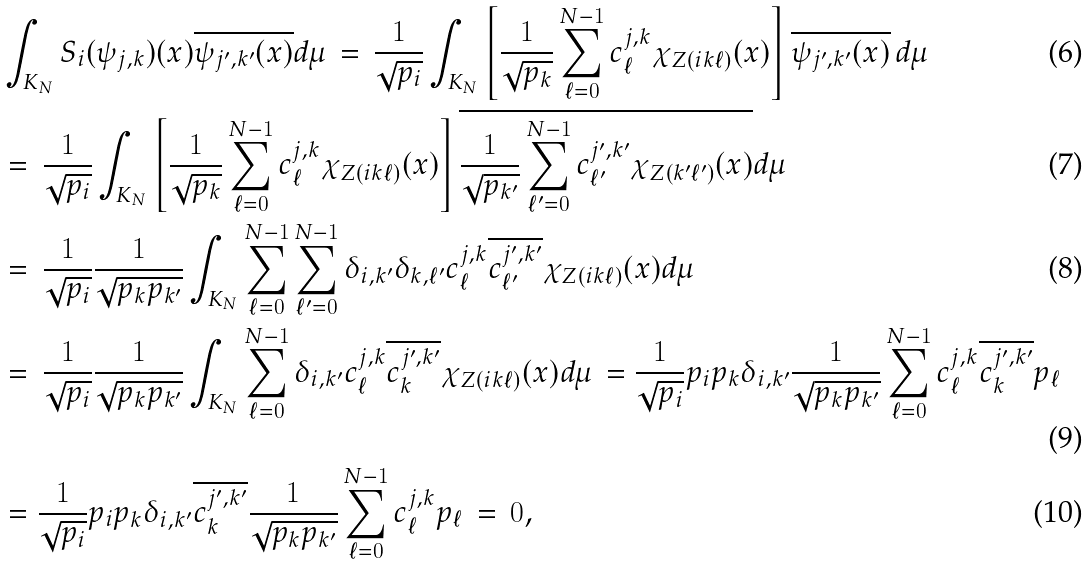<formula> <loc_0><loc_0><loc_500><loc_500>& \int _ { K _ { N } } S _ { i } ( \psi _ { j , k } ) ( x ) \overline { \psi _ { j ^ { \prime } , k ^ { \prime } } ( x ) } d \mu \, = \, \frac { 1 } { \sqrt { p _ { i } } } \int _ { K _ { N } } \left [ \frac { 1 } { \sqrt { p _ { k } } } \sum _ { \ell = 0 } ^ { N - 1 } c ^ { j , k } _ { \ell } \chi _ { Z ( i k \ell ) } ( x ) \right ] \overline { \psi _ { j ^ { \prime } , k ^ { \prime } } ( x ) } \, d \mu \\ & = \, \frac { 1 } { \sqrt { p _ { i } } } \int _ { K _ { N } } \left [ \frac { 1 } { \sqrt { p _ { k } } } \sum _ { \ell = 0 } ^ { N - 1 } c ^ { j , k } _ { \ell } \chi _ { Z ( i k \ell ) } ( x ) \right ] \overline { \frac { 1 } { \sqrt { p _ { k ^ { \prime } } } } \sum _ { \ell ^ { \prime } = 0 } ^ { N - 1 } c ^ { j ^ { \prime } , k ^ { \prime } } _ { \ell ^ { \prime } } \chi _ { Z ( k ^ { \prime } \ell ^ { \prime } ) } ( x ) } d \mu \\ & = \, \frac { 1 } { \sqrt { p _ { i } } } \frac { 1 } { \sqrt { p _ { k } p _ { k ^ { \prime } } } } \int _ { K _ { N } } \sum _ { \ell = 0 } ^ { N - 1 } \sum _ { \ell ^ { \prime } = 0 } ^ { N - 1 } \delta _ { i , k ^ { \prime } } \delta _ { k , \ell ^ { \prime } } c ^ { j , k } _ { \ell } \overline { c ^ { j ^ { \prime } , k ^ { \prime } } _ { \ell ^ { \prime } } } \chi _ { Z ( i k \ell ) } ( x ) d \mu \\ & = \, \frac { 1 } { \sqrt { p _ { i } } } \frac { 1 } { \sqrt { p _ { k } p _ { k ^ { \prime } } } } \int _ { K _ { N } } \sum _ { \ell = 0 } ^ { N - 1 } \delta _ { i , k ^ { \prime } } c ^ { j , k } _ { \ell } \overline { c ^ { j ^ { \prime } , k ^ { \prime } } _ { k } } \chi _ { Z ( i k \ell ) } ( x ) d \mu \, = \frac { 1 } { \sqrt { p _ { i } } } p _ { i } p _ { k } \delta _ { i , k ^ { \prime } } \frac { 1 } { \sqrt { p _ { k } p _ { k ^ { \prime } } } } \sum _ { \ell = 0 } ^ { N - 1 } c ^ { j , k } _ { \ell } \overline { c ^ { j ^ { \prime } , k ^ { \prime } } _ { k } } p _ { \ell } \\ & = \frac { 1 } { \sqrt { p _ { i } } } p _ { i } p _ { k } \delta _ { i , k ^ { \prime } } \overline { c ^ { j ^ { \prime } , k ^ { \prime } } _ { k } } \frac { 1 } { \sqrt { p _ { k } p _ { k ^ { \prime } } } } \sum _ { \ell = 0 } ^ { N - 1 } c ^ { j , k } _ { \ell } p _ { \ell } \, = \, 0 ,</formula> 